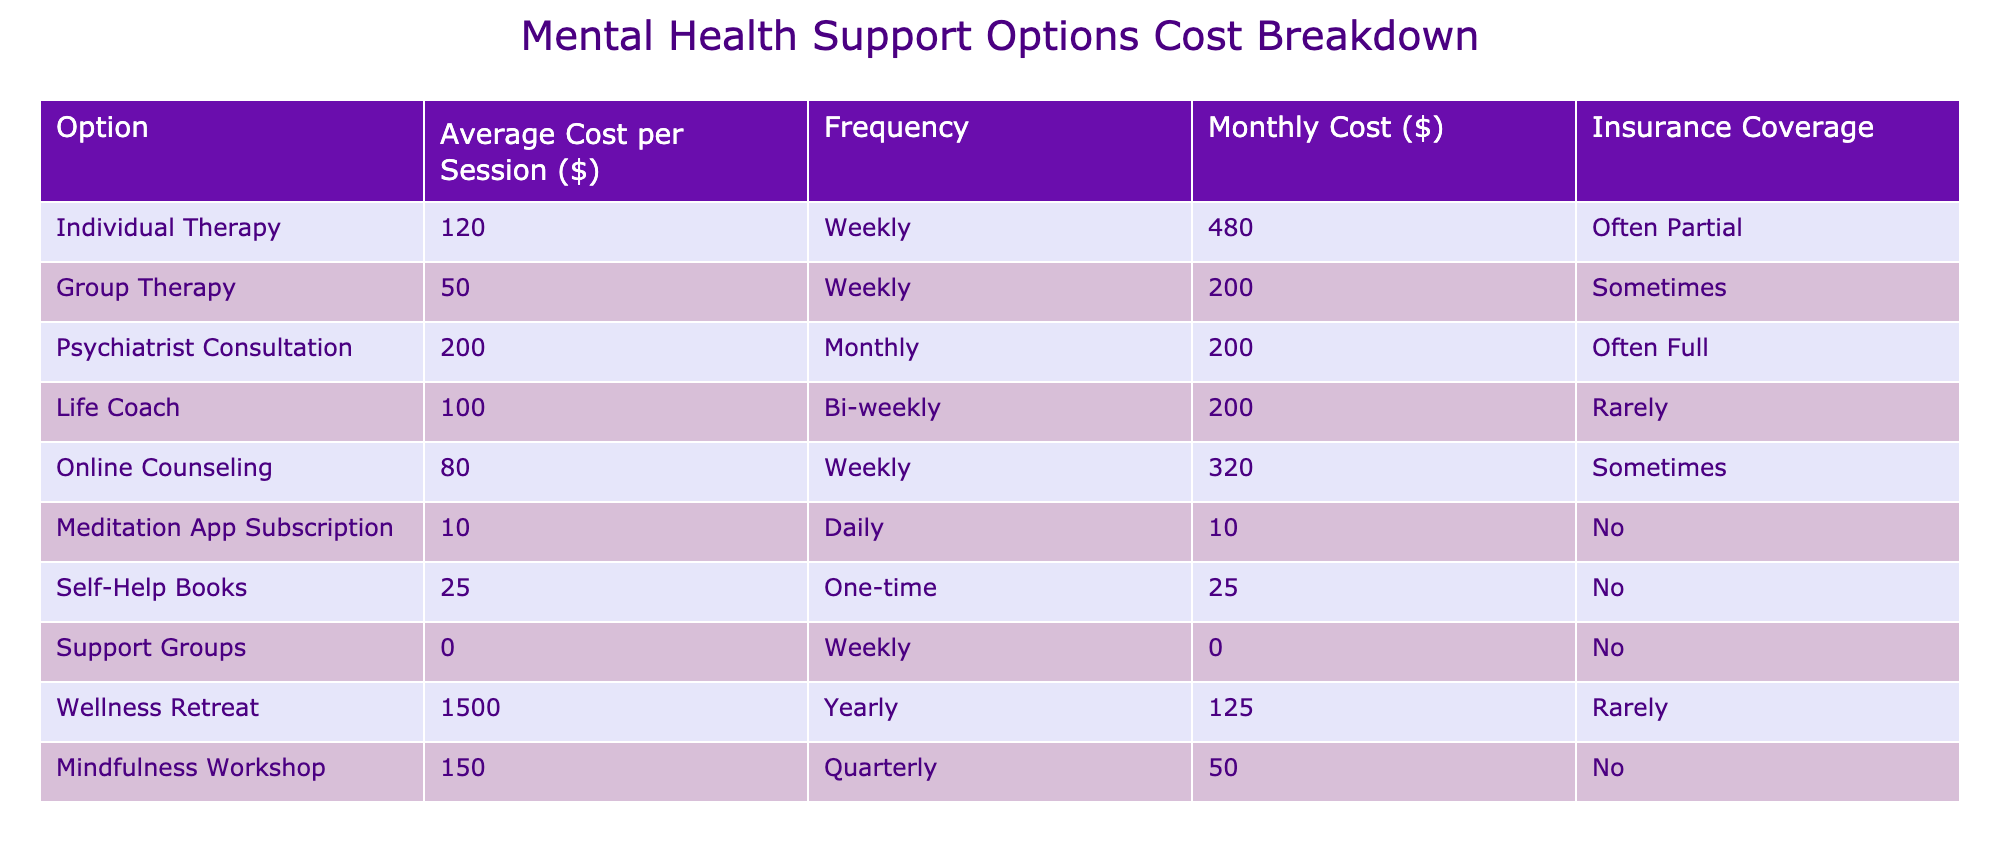What is the average cost per session for Individual Therapy? The average cost per session for Individual Therapy is explicitly listed in the table as $120.
Answer: 120 How often do most people attend Group Therapy based on the table? The frequency of Group Therapy sessions is indicated as "Weekly" in the table.
Answer: Weekly What is the total monthly cost for attending Online Counseling? The table shows that the monthly cost for Online Counseling is $320.
Answer: 320 Which mental health support option has the highest yearly cost? The Wellness Retreat has a yearly cost of $1500, which is the highest compared to other options listed.
Answer: Wellness Retreat Is insurance coverage for Life Coaches typically provided? According to the table, it states that insurance coverage for Life Coaches is "Rarely," indicating infrequent coverage.
Answer: No What is the combined monthly cost for both Individual Therapy and Online Counseling? The monthly cost for Individual Therapy is $480 and for Online Counseling is $320. Adding these two gives $480 + $320 = $800.
Answer: 800 How much more expensive is Psychiatrist Consultation compared to Group Therapy per session? The average cost per session for Psychiatrist Consultation is $200, while Group Therapy is $50. Therefore, $200 - $50 = $150 more expensive.
Answer: 150 If someone attends a Support Group weekly, what will be the total costs in a month? The table shows that Support Groups are $0 per session. Therefore, if attended weekly, the total would be $0 for 4 weeks, resulting in a total cost of $0.
Answer: 0 How many options have insurance coverage listed as full? In the table, the only mental health support option with insurance coverage marked as "Often Full" is the Psychiatrist Consultation.
Answer: 1 